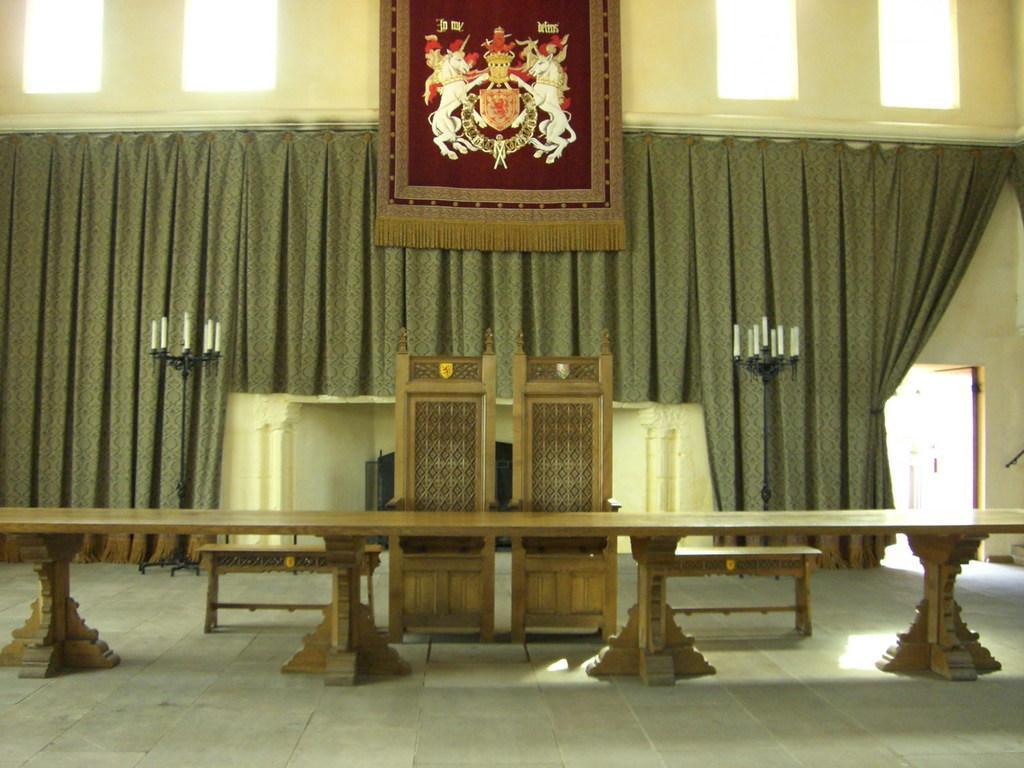How would you summarize this image in a sentence or two? In this image we can see the chairs, benches and also the wooden table. In the background we can see the curtain, door, wall, candles and also the ventilators. We can also see some mat. At the bottom we can see the floor. 